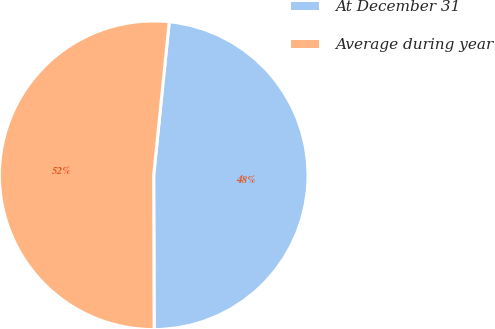<chart> <loc_0><loc_0><loc_500><loc_500><pie_chart><fcel>At December 31<fcel>Average during year<nl><fcel>48.35%<fcel>51.65%<nl></chart> 